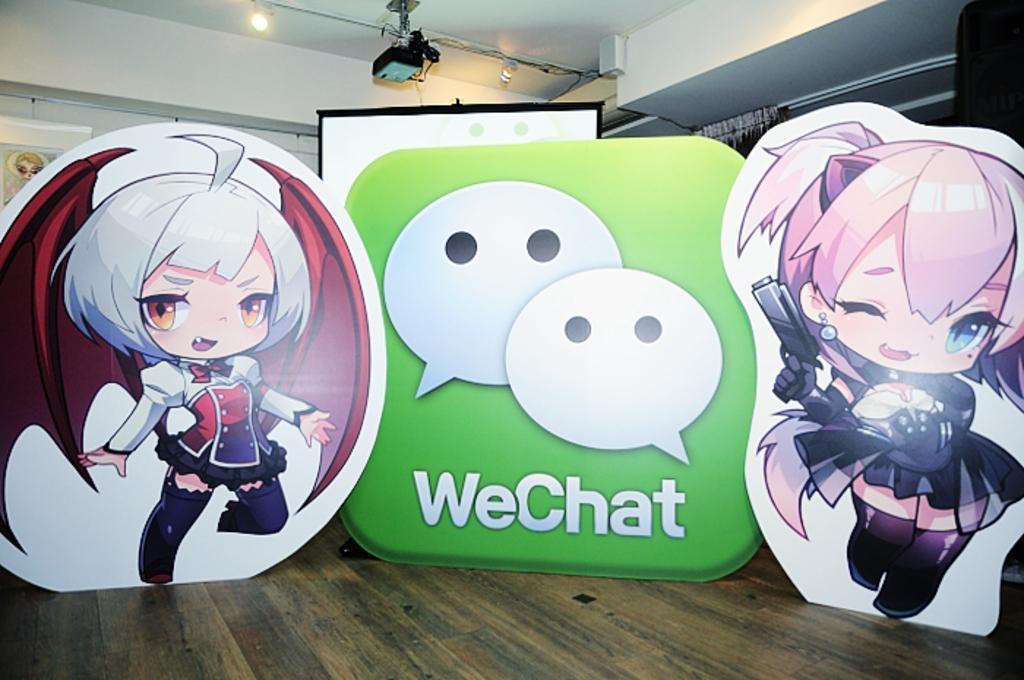How would you summarize this image in a sentence or two? This is an edited image. In front of the picture, we see the boards of cartoons. We see a green color thing on which ¨We Chat¨ is written. Behind that, we see a projector screen. In the background, we see a white wall on which photo frame is placed. At the top of the picture, we see the light and a projector. 